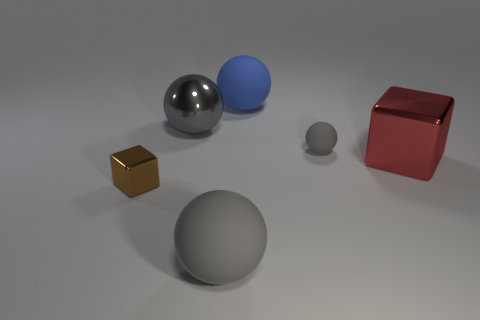Do the tiny sphere and the big red object have the same material?
Give a very brief answer. No. There is a big red cube that is to the right of the tiny gray matte ball; what number of balls are in front of it?
Ensure brevity in your answer.  1. Does the brown cube have the same size as the blue ball?
Ensure brevity in your answer.  No. How many tiny cylinders are made of the same material as the big blue object?
Make the answer very short. 0. What is the size of the gray metallic thing that is the same shape as the big blue matte object?
Your answer should be very brief. Large. Does the small gray matte object that is in front of the large blue object have the same shape as the big gray matte object?
Offer a terse response. Yes. What is the shape of the large metal thing in front of the metallic object that is behind the small gray thing?
Provide a short and direct response. Cube. Are there any other things that are the same shape as the tiny brown metal object?
Offer a terse response. Yes. What color is the other metal object that is the same shape as the big red metal object?
Provide a succinct answer. Brown. Is the color of the small rubber sphere the same as the thing that is left of the gray shiny sphere?
Offer a terse response. No. 